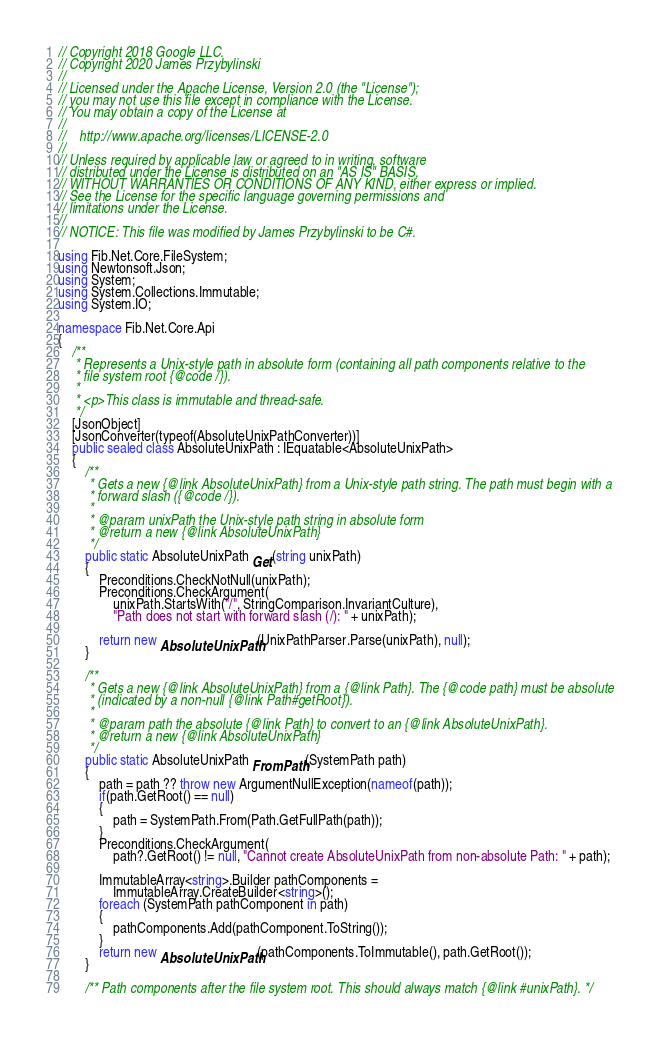<code> <loc_0><loc_0><loc_500><loc_500><_C#_>// Copyright 2018 Google LLC.
// Copyright 2020 James Przybylinski
//
// Licensed under the Apache License, Version 2.0 (the "License");
// you may not use this file except in compliance with the License.
// You may obtain a copy of the License at
//
//    http://www.apache.org/licenses/LICENSE-2.0
//
// Unless required by applicable law or agreed to in writing, software
// distributed under the License is distributed on an "AS IS" BASIS,
// WITHOUT WARRANTIES OR CONDITIONS OF ANY KIND, either express or implied.
// See the License for the specific language governing permissions and
// limitations under the License.
//
// NOTICE: This file was modified by James Przybylinski to be C#.

using Fib.Net.Core.FileSystem;
using Newtonsoft.Json;
using System;
using System.Collections.Immutable;
using System.IO;

namespace Fib.Net.Core.Api
{
    /**
     * Represents a Unix-style path in absolute form (containing all path components relative to the
     * file system root {@code /}).
     *
     * <p>This class is immutable and thread-safe.
     */
    [JsonObject]
    [JsonConverter(typeof(AbsoluteUnixPathConverter))]
    public sealed class AbsoluteUnixPath : IEquatable<AbsoluteUnixPath>
    {
        /**
         * Gets a new {@link AbsoluteUnixPath} from a Unix-style path string. The path must begin with a
         * forward slash ({@code /}).
         *
         * @param unixPath the Unix-style path string in absolute form
         * @return a new {@link AbsoluteUnixPath}
         */
        public static AbsoluteUnixPath Get(string unixPath)
        {
            Preconditions.CheckNotNull(unixPath);
            Preconditions.CheckArgument(
                unixPath.StartsWith("/", StringComparison.InvariantCulture),
                "Path does not start with forward slash (/): " + unixPath);

            return new AbsoluteUnixPath(UnixPathParser.Parse(unixPath), null);
        }

        /**
         * Gets a new {@link AbsoluteUnixPath} from a {@link Path}. The {@code path} must be absolute
         * (indicated by a non-null {@link Path#getRoot}).
         *
         * @param path the absolute {@link Path} to convert to an {@link AbsoluteUnixPath}.
         * @return a new {@link AbsoluteUnixPath}
         */
        public static AbsoluteUnixPath FromPath(SystemPath path)
        {
            path = path ?? throw new ArgumentNullException(nameof(path));
            if(path.GetRoot() == null)
            {
                path = SystemPath.From(Path.GetFullPath(path));
            }
            Preconditions.CheckArgument(
                path?.GetRoot() != null, "Cannot create AbsoluteUnixPath from non-absolute Path: " + path);

            ImmutableArray<string>.Builder pathComponents =
                ImmutableArray.CreateBuilder<string>();
            foreach (SystemPath pathComponent in path)
            {
                pathComponents.Add(pathComponent.ToString());
            }
            return new AbsoluteUnixPath(pathComponents.ToImmutable(), path.GetRoot());
        }

        /** Path components after the file system root. This should always match {@link #unixPath}. */</code> 